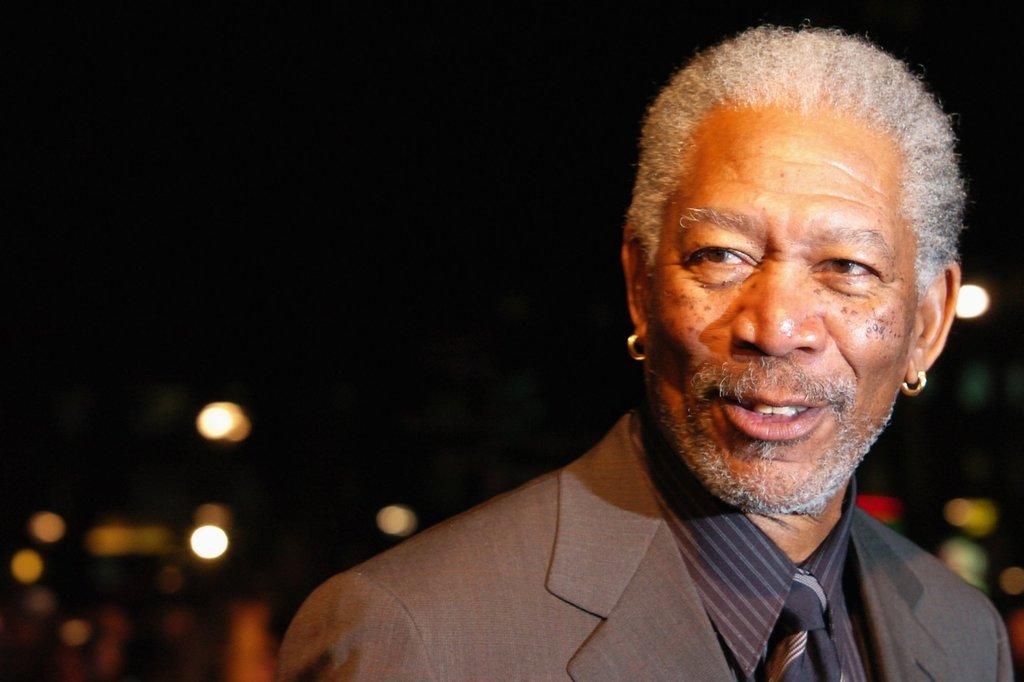What is the main subject of the image? There is a person in the image. What is the person wearing? The person is wearing a brown suit. What is the person's facial expression? The person is smiling. What type of accessory is the person wearing? The person is wearing earrings. What can be seen in the background of the image? The background of the image is blurry. What is visible at the top of the image? The sky is visible at the top of the image. Can you tell me how many wheels on the person's suit in the image? There are no wheels present on the person's suit in the image. Is there an airport visible in the background of the image? There is no airport visible in the background of the image; the background is blurry. 